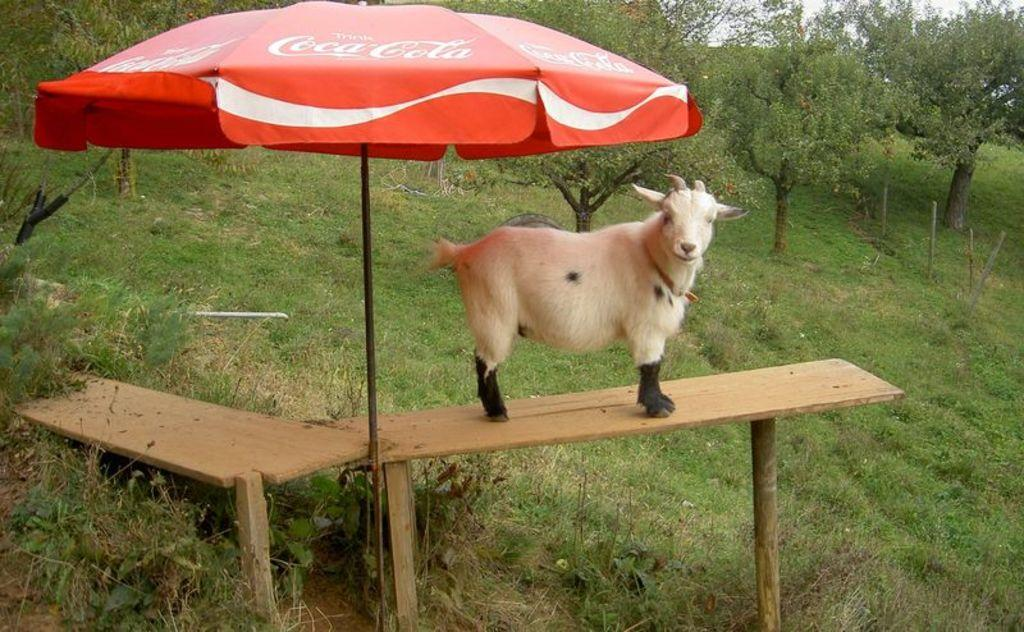How many tables can be seen in the image? There are two tables in the image. What is printed on one of the tables? There is an umbrella printed on one of the tables. What part of an animal is visible in the image? The back side of a sheep is visible in the image. What type of vegetation is present in the image? There are trees and grass in the image. What type of hope can be seen supporting the sheep in the image? There is no hope or support present in the image; it features two tables, an umbrella print, and a sheep. What kind of joke is being told by the trees in the image? There is no joke being told by the trees in the image; it features trees and grass as part of the natural environment. 